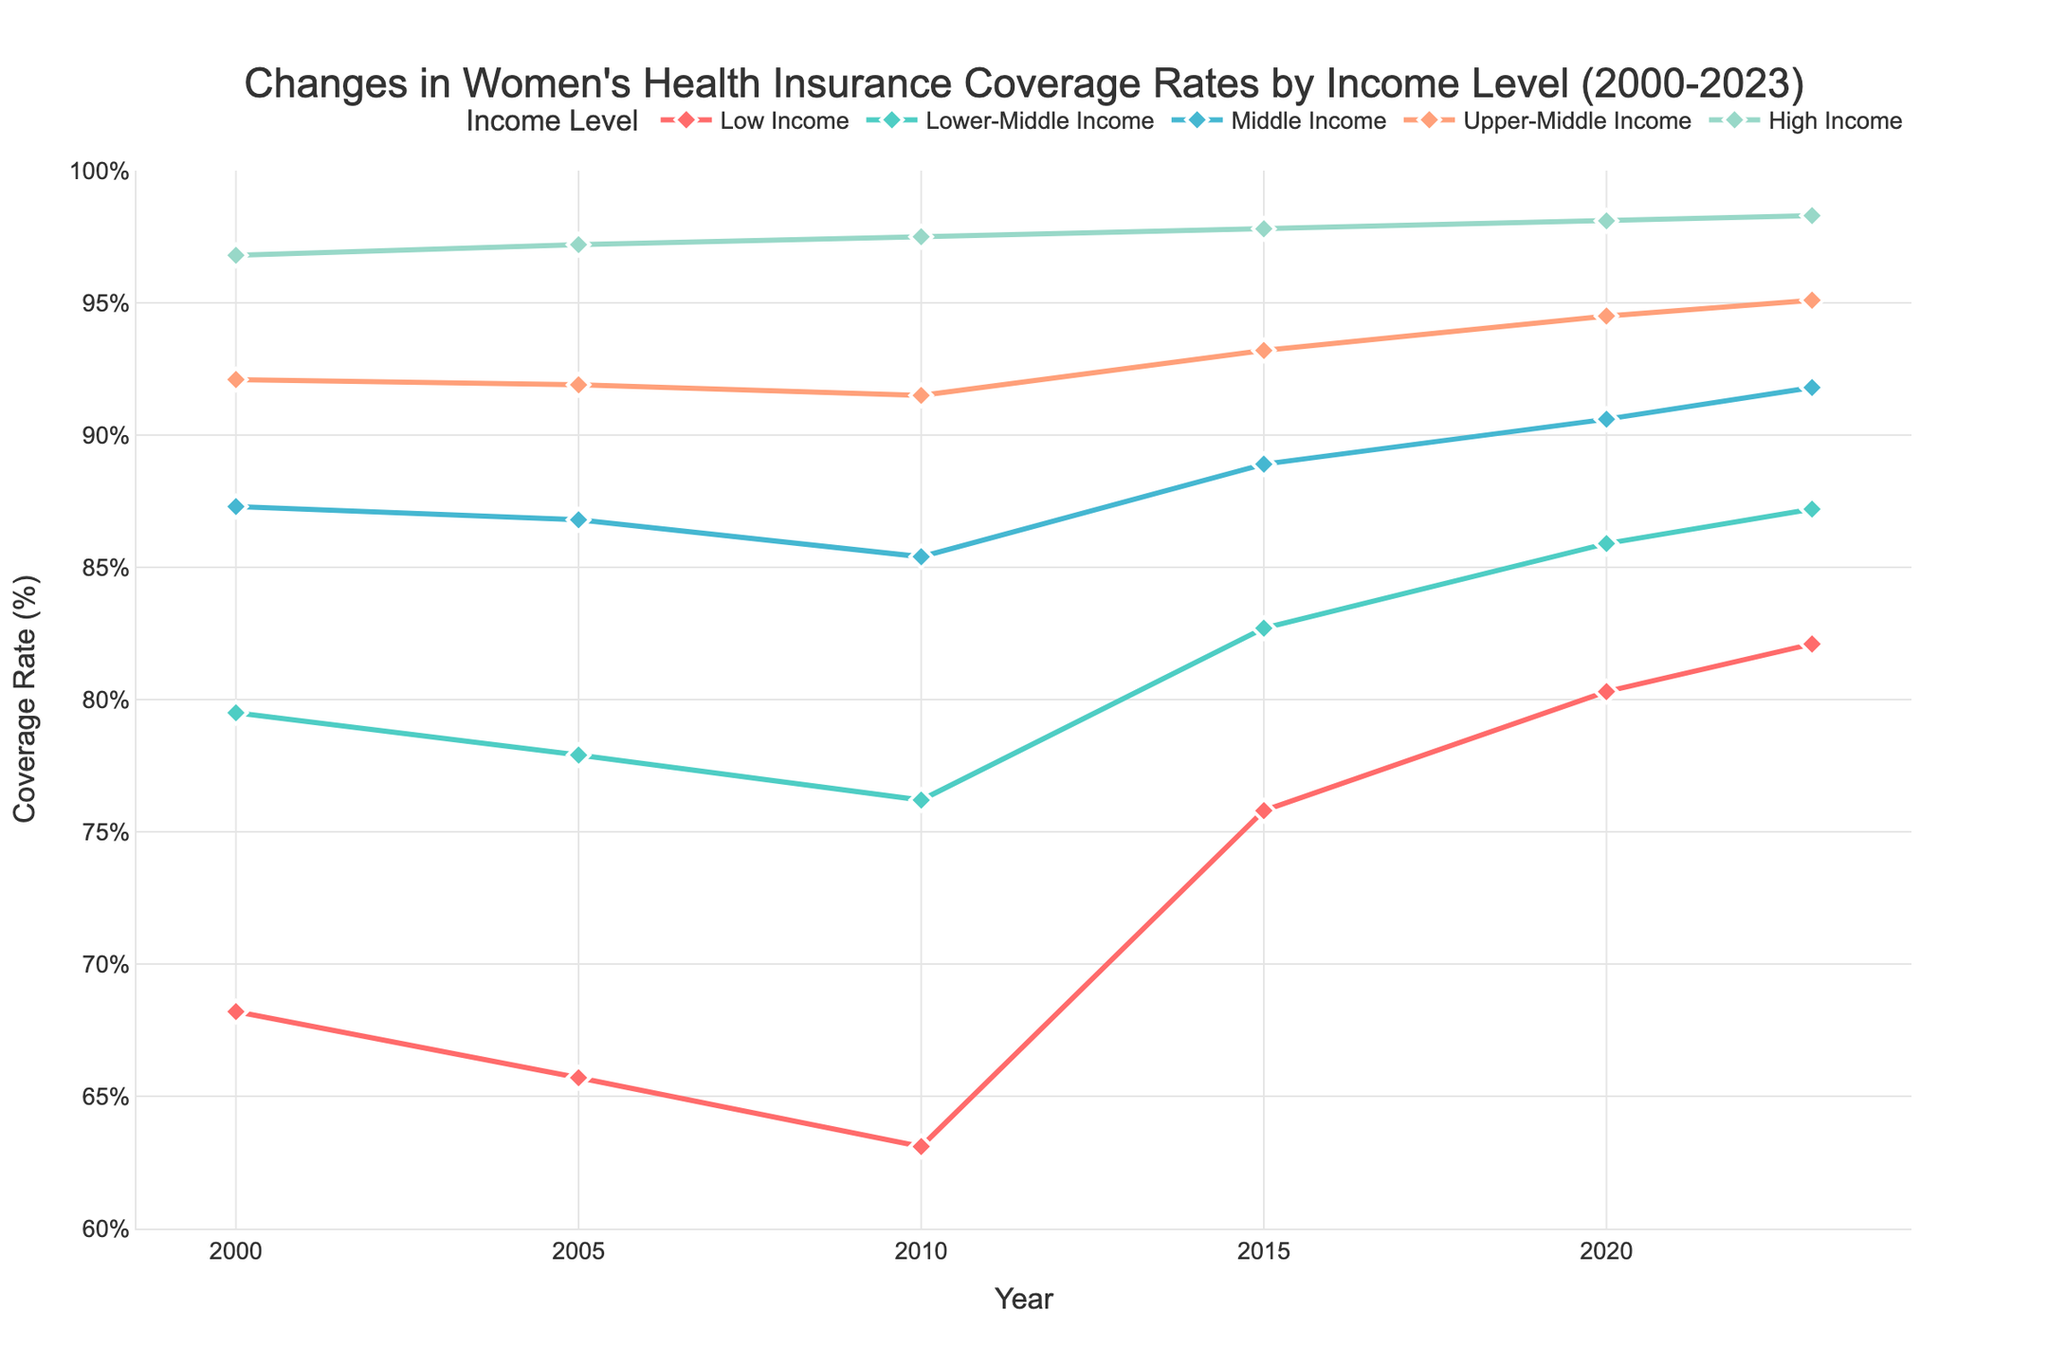What is the coverage rate for High Income women in 2005? Look at the data points for High Income in the year 2005. The coverage rate is 97.2%.
Answer: 97.2% Which income group had the lowest coverage rate in 2023? Compare the coverage rates across all income groups for the year 2023. The Low Income group has the lowest rate at 82.1%.
Answer: Low Income How did the coverage rate for Low Income women change from 2000 to 2010? Find the coverage rates for Low Income group in 2000 and 2010. The coverage rate in 2000 was 68.2% and in 2010 it was 63.1%, so it decreased by 5.1%.
Answer: Decreased by 5.1% Which income group saw the greatest increase in coverage rates from 2010 to 2023? Calculate the difference in coverage rates from 2010 to 2023 for each income group. Low Income had the highest increase from 63.1% to 82.1%, which is an increase of 19%.
Answer: Low Income What is the trend in coverage rates for Upper-Middle Income women from 2000 to 2023? Look at the coverage rates for Upper-Middle Income over the years. The trend is a gradual increase from 92.1% in 2000 to 95.1% in 2023.
Answer: Increasing Between which consecutive years did Lower-Middle Income women see the largest increase in coverage rates? Calculate the yearly differences for Lower-Middle Income: (77.9 - 79.5), (76.2 - 77.9), (82.7 - 76.2), (85.9 - 82.7), and (87.2 - 85.9). The largest increase was between 2010 and 2015 with a difference of 6.5%.
Answer: 2010 and 2015 On the chart, what color represents the High Income group? Identify the line color associated with the High Income group on the chart. The High Income group is represented by the color light green/teal.
Answer: Light Green/Teal In 2020, which income groups had coverage rates above 90%? Look at the coverage rates for each income group in 2020. Middle Income (90.6%), Upper-Middle Income (94.5%), and High Income (98.1%) all had rates above 90%.
Answer: Middle Income, Upper-Middle Income, High Income What is the average coverage rate for the Middle Income group across all years? Sum the coverage rates for Middle Income across all years (87.3 + 86.8 + 85.4 + 88.9 + 90.6 + 91.8) and divide by the number of years (6). The average is (530.8 / 6) = 88.47%.
Answer: 88.47% How did the coverage rates for Low Income black women compare to those for Middle Income white women from 2000 to 2023? Compare the line patterns and data points of Low Income black women and Middle Income white women over the years. Low Income black women's rates show a significant increase from 68.2% to 82.1%, while Middle Income white women had a more moderate increase from 87.3% to 91.8%.
Answer: Low Income black women had a significant increase, while Middle Income white women had a moderate increase 